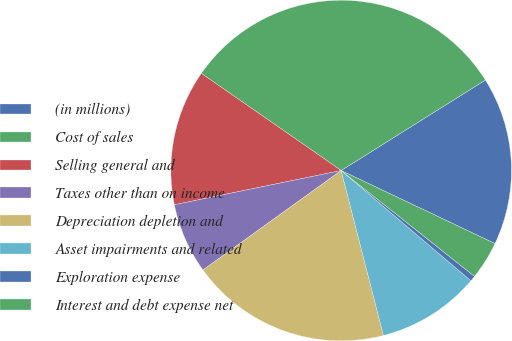<chart> <loc_0><loc_0><loc_500><loc_500><pie_chart><fcel>(in millions)<fcel>Cost of sales<fcel>Selling general and<fcel>Taxes other than on income<fcel>Depreciation depletion and<fcel>Asset impairments and related<fcel>Exploration expense<fcel>Interest and debt expense net<nl><fcel>15.98%<fcel>31.43%<fcel>12.89%<fcel>6.71%<fcel>19.07%<fcel>9.8%<fcel>0.53%<fcel>3.62%<nl></chart> 